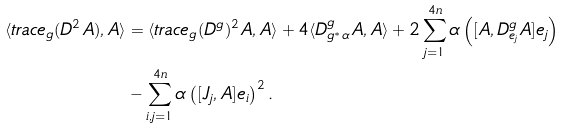<formula> <loc_0><loc_0><loc_500><loc_500>\langle t r a c e _ { g } ( D ^ { 2 } A ) , A \rangle & = \langle t r a c e _ { g } ( D ^ { g } ) ^ { 2 } A , A \rangle + 4 \langle D ^ { g } _ { g ^ { * } \alpha } A , A \rangle + 2 \sum _ { j = 1 } ^ { 4 n } \alpha \left ( [ A , D ^ { g } _ { e _ { j } } A ] e _ { j } \right ) \\ & - \sum _ { i , j = 1 } ^ { 4 n } \alpha \left ( [ J _ { j } , A ] e _ { i } \right ) ^ { 2 } .</formula> 